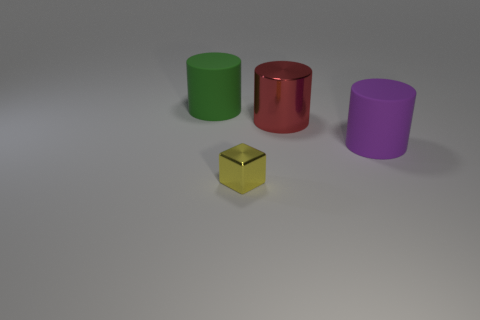Subtract all purple rubber cylinders. How many cylinders are left? 2 Add 1 yellow spheres. How many objects exist? 5 Subtract all purple cylinders. How many cylinders are left? 2 Subtract all tiny purple metallic cubes. Subtract all red metallic things. How many objects are left? 3 Add 2 tiny things. How many tiny things are left? 3 Add 2 tiny red rubber objects. How many tiny red rubber objects exist? 2 Subtract 0 cyan cylinders. How many objects are left? 4 Subtract all cylinders. How many objects are left? 1 Subtract 1 cylinders. How many cylinders are left? 2 Subtract all yellow cylinders. Subtract all yellow cubes. How many cylinders are left? 3 